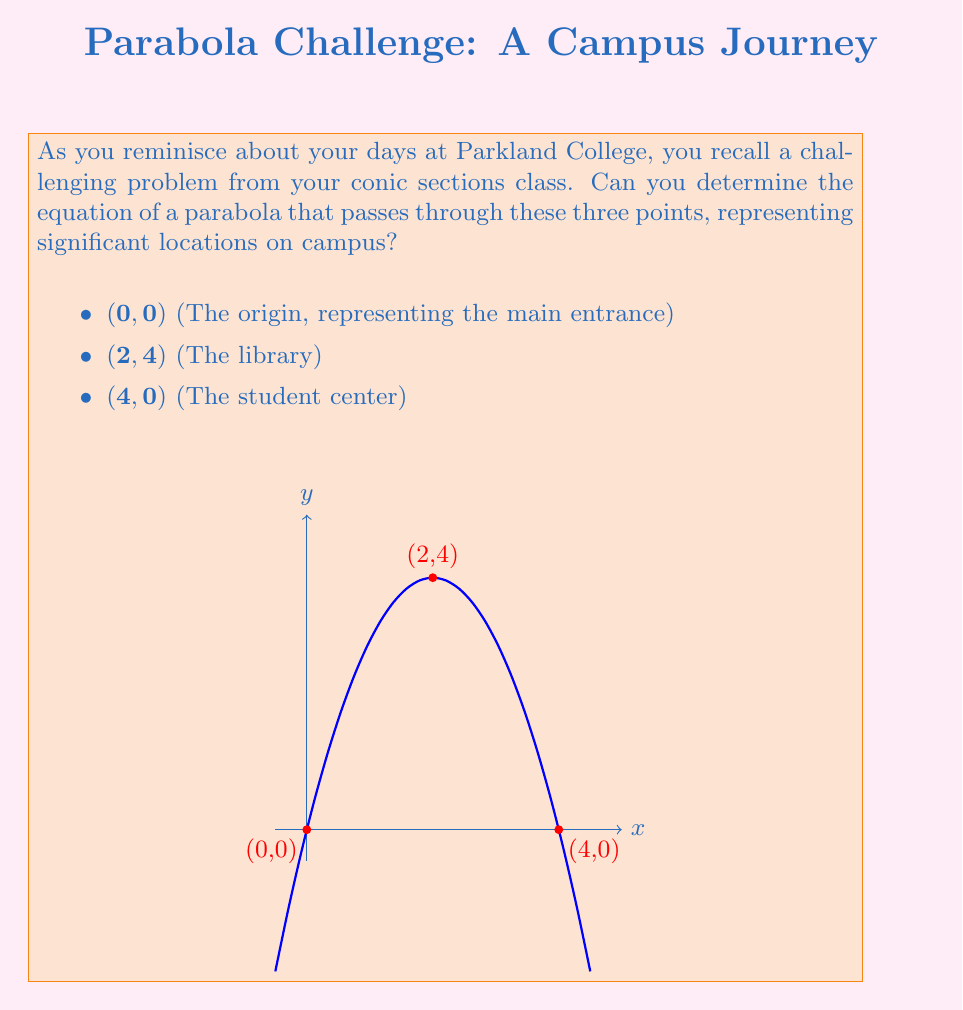Provide a solution to this math problem. Let's approach this step-by-step:

1) The general equation of a parabola with a vertical axis of symmetry is:

   $$y = ax^2 + bx + c$$

2) We need to find the values of $a$, $b$, and $c$. We can do this by substituting our three points into this equation:

   For (0,0): $0 = a(0)^2 + b(0) + c$, so $c = 0$
   For (2,4): $4 = a(2)^2 + b(2) + 0$
   For (4,0): $0 = a(4)^2 + b(4) + 0$

3) From the second equation:
   $$4 = 4a + 2b$$ ... (Eq. 1)

4) From the third equation:
   $$0 = 16a + 4b$$ ... (Eq. 2)

5) Multiply Eq. 1 by 2:
   $$8 = 8a + 4b$$ ... (Eq. 3)

6) Subtract Eq. 2 from Eq. 3:
   $$8 = -8a$$
   $$a = -1$$

7) Substitute this value of $a$ back into Eq. 1:
   $$4 = 4(-1) + 2b$$
   $$4 = -4 + 2b$$
   $$8 = 2b$$
   $$b = 4$$

8) We now have $a = -1$, $b = 4$, and $c = 0$

Therefore, the equation of the parabola is:

$$y = -x^2 + 4x$$
Answer: $$y = -x^2 + 4x$$ 